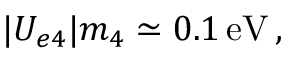<formula> <loc_0><loc_0><loc_500><loc_500>| U _ { e 4 } | m _ { 4 } \simeq 0 . 1 \, e V \, ,</formula> 